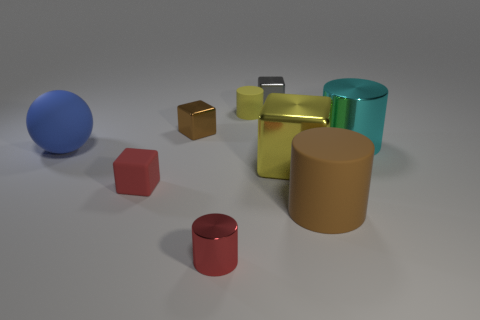Subtract all green blocks. Subtract all blue spheres. How many blocks are left? 4 Add 1 gray matte spheres. How many objects exist? 10 Subtract all cubes. How many objects are left? 5 Add 8 gray cylinders. How many gray cylinders exist? 8 Subtract 1 brown cylinders. How many objects are left? 8 Subtract all tiny blue things. Subtract all large yellow blocks. How many objects are left? 8 Add 3 tiny cylinders. How many tiny cylinders are left? 5 